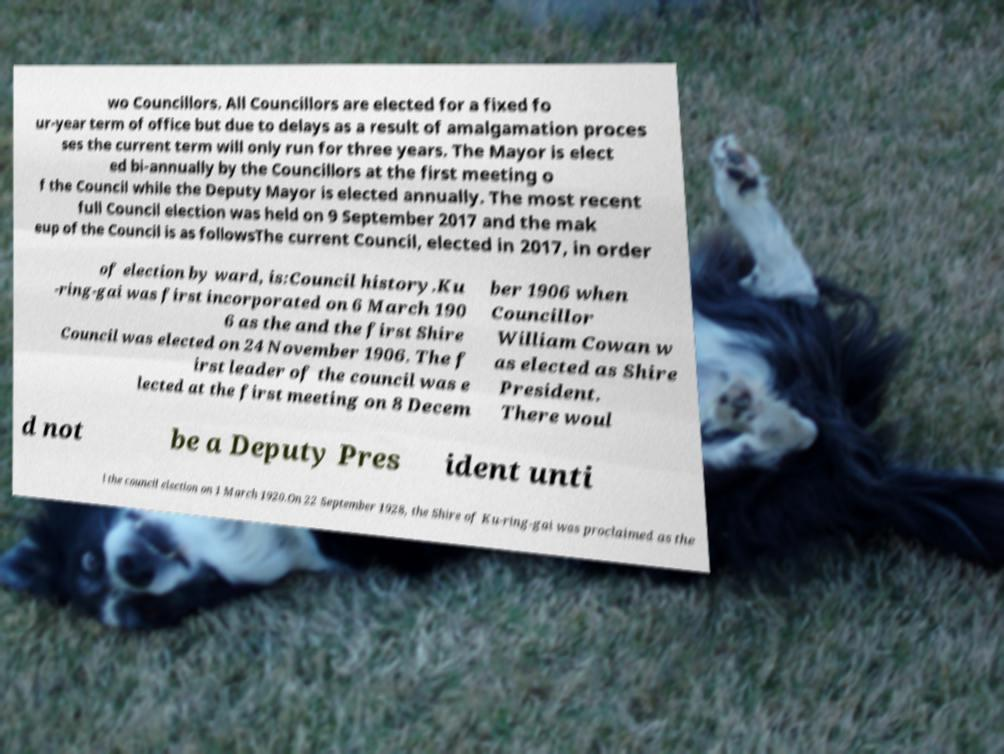I need the written content from this picture converted into text. Can you do that? wo Councillors. All Councillors are elected for a fixed fo ur-year term of office but due to delays as a result of amalgamation proces ses the current term will only run for three years. The Mayor is elect ed bi-annually by the Councillors at the first meeting o f the Council while the Deputy Mayor is elected annually. The most recent full Council election was held on 9 September 2017 and the mak eup of the Council is as followsThe current Council, elected in 2017, in order of election by ward, is:Council history.Ku -ring-gai was first incorporated on 6 March 190 6 as the and the first Shire Council was elected on 24 November 1906. The f irst leader of the council was e lected at the first meeting on 8 Decem ber 1906 when Councillor William Cowan w as elected as Shire President. There woul d not be a Deputy Pres ident unti l the council election on 1 March 1920.On 22 September 1928, the Shire of Ku-ring-gai was proclaimed as the 